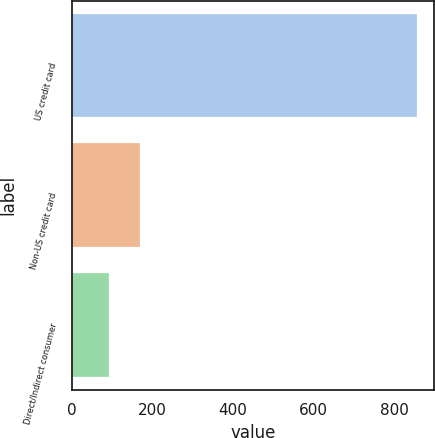Convert chart. <chart><loc_0><loc_0><loc_500><loc_500><bar_chart><fcel>US credit card<fcel>Non-US credit card<fcel>Direct/Indirect consumer<nl><fcel>856<fcel>168.4<fcel>92<nl></chart> 